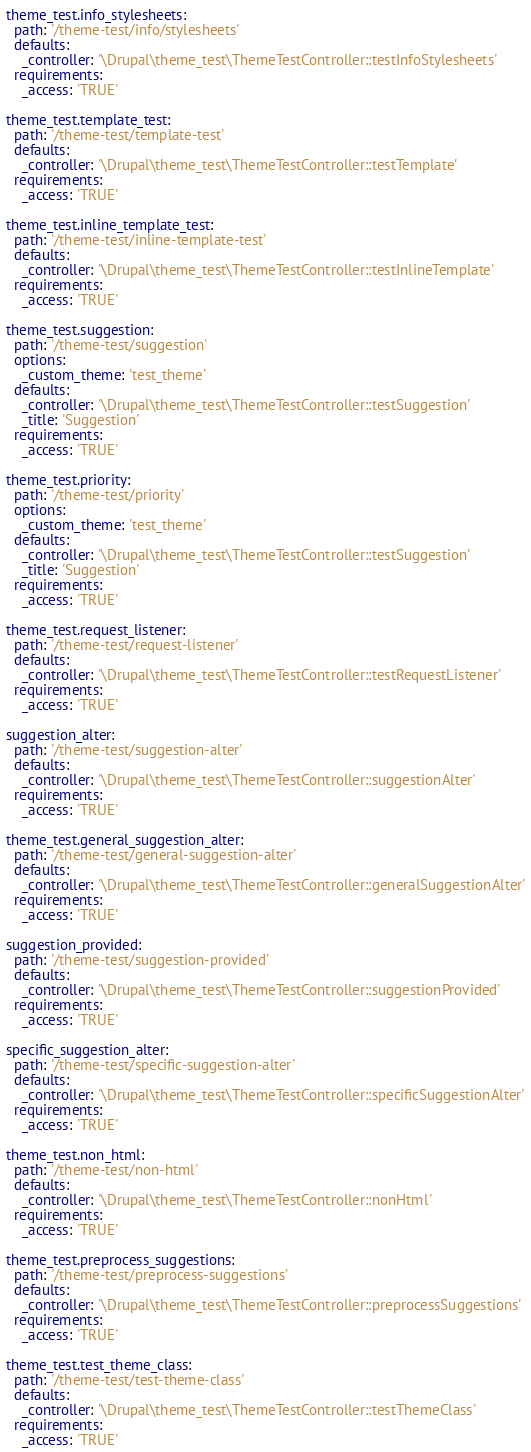<code> <loc_0><loc_0><loc_500><loc_500><_YAML_>theme_test.info_stylesheets:
  path: '/theme-test/info/stylesheets'
  defaults:
    _controller: '\Drupal\theme_test\ThemeTestController::testInfoStylesheets'
  requirements:
    _access: 'TRUE'

theme_test.template_test:
  path: '/theme-test/template-test'
  defaults:
    _controller: '\Drupal\theme_test\ThemeTestController::testTemplate'
  requirements:
    _access: 'TRUE'

theme_test.inline_template_test:
  path: '/theme-test/inline-template-test'
  defaults:
    _controller: '\Drupal\theme_test\ThemeTestController::testInlineTemplate'
  requirements:
    _access: 'TRUE'

theme_test.suggestion:
  path: '/theme-test/suggestion'
  options:
    _custom_theme: 'test_theme'
  defaults:
    _controller: '\Drupal\theme_test\ThemeTestController::testSuggestion'
    _title: 'Suggestion'
  requirements:
    _access: 'TRUE'

theme_test.priority:
  path: '/theme-test/priority'
  options:
    _custom_theme: 'test_theme'
  defaults:
    _controller: '\Drupal\theme_test\ThemeTestController::testSuggestion'
    _title: 'Suggestion'
  requirements:
    _access: 'TRUE'

theme_test.request_listener:
  path: '/theme-test/request-listener'
  defaults:
    _controller: '\Drupal\theme_test\ThemeTestController::testRequestListener'
  requirements:
    _access: 'TRUE'

suggestion_alter:
  path: '/theme-test/suggestion-alter'
  defaults:
    _controller: '\Drupal\theme_test\ThemeTestController::suggestionAlter'
  requirements:
    _access: 'TRUE'

theme_test.general_suggestion_alter:
  path: '/theme-test/general-suggestion-alter'
  defaults:
    _controller: '\Drupal\theme_test\ThemeTestController::generalSuggestionAlter'
  requirements:
    _access: 'TRUE'

suggestion_provided:
  path: '/theme-test/suggestion-provided'
  defaults:
    _controller: '\Drupal\theme_test\ThemeTestController::suggestionProvided'
  requirements:
    _access: 'TRUE'

specific_suggestion_alter:
  path: '/theme-test/specific-suggestion-alter'
  defaults:
    _controller: '\Drupal\theme_test\ThemeTestController::specificSuggestionAlter'
  requirements:
    _access: 'TRUE'

theme_test.non_html:
  path: '/theme-test/non-html'
  defaults:
    _controller: '\Drupal\theme_test\ThemeTestController::nonHtml'
  requirements:
    _access: 'TRUE'

theme_test.preprocess_suggestions:
  path: '/theme-test/preprocess-suggestions'
  defaults:
    _controller: '\Drupal\theme_test\ThemeTestController::preprocessSuggestions'
  requirements:
    _access: 'TRUE'

theme_test.test_theme_class:
  path: '/theme-test/test-theme-class'
  defaults:
    _controller: '\Drupal\theme_test\ThemeTestController::testThemeClass'
  requirements:
    _access: 'TRUE'
</code> 